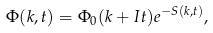Convert formula to latex. <formula><loc_0><loc_0><loc_500><loc_500>\Phi ( k , t ) = \Phi _ { 0 } ( k + I t ) e ^ { - S ( k , t ) } ,</formula> 